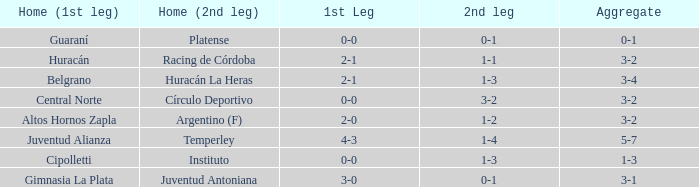What was the score of the 2nd leg when the Belgrano played the first leg at home with a score of 2-1? 1-3. 